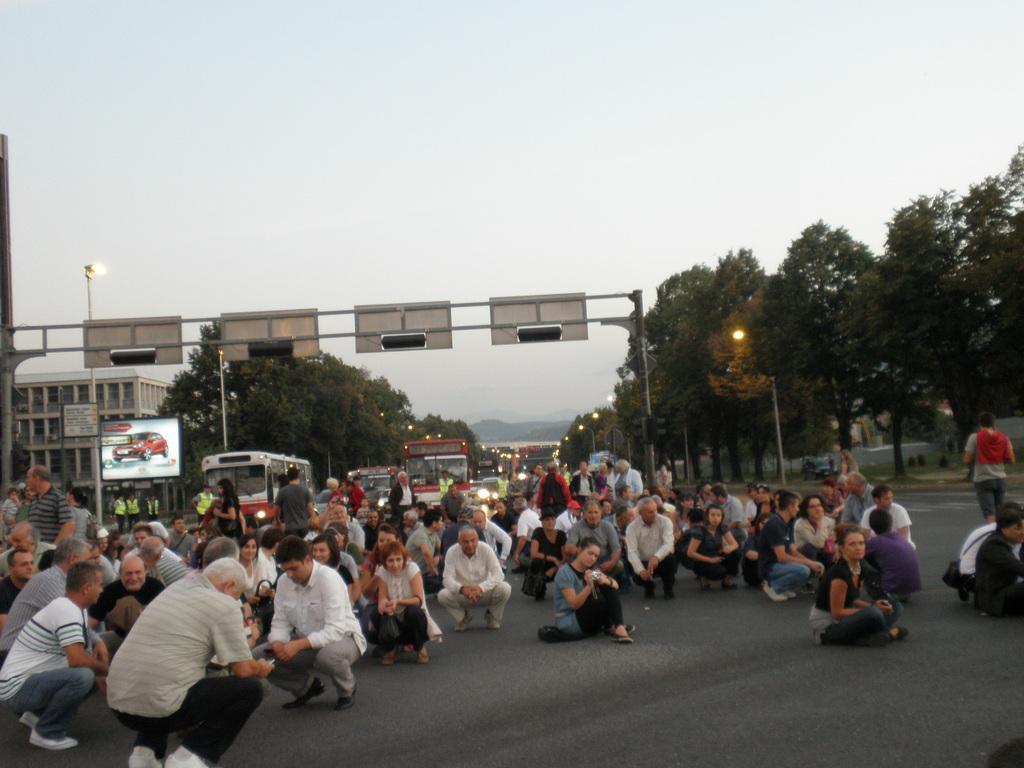Describe this image in one or two sentences. There are many people on the road. In the back there are vehicles. Also there is a stand across the road. On the stand there are boards. Also there are light poles. On the sides of the road there are trees and lights. On the left side there is a building. Also there is a screen. In the background there is sky. 